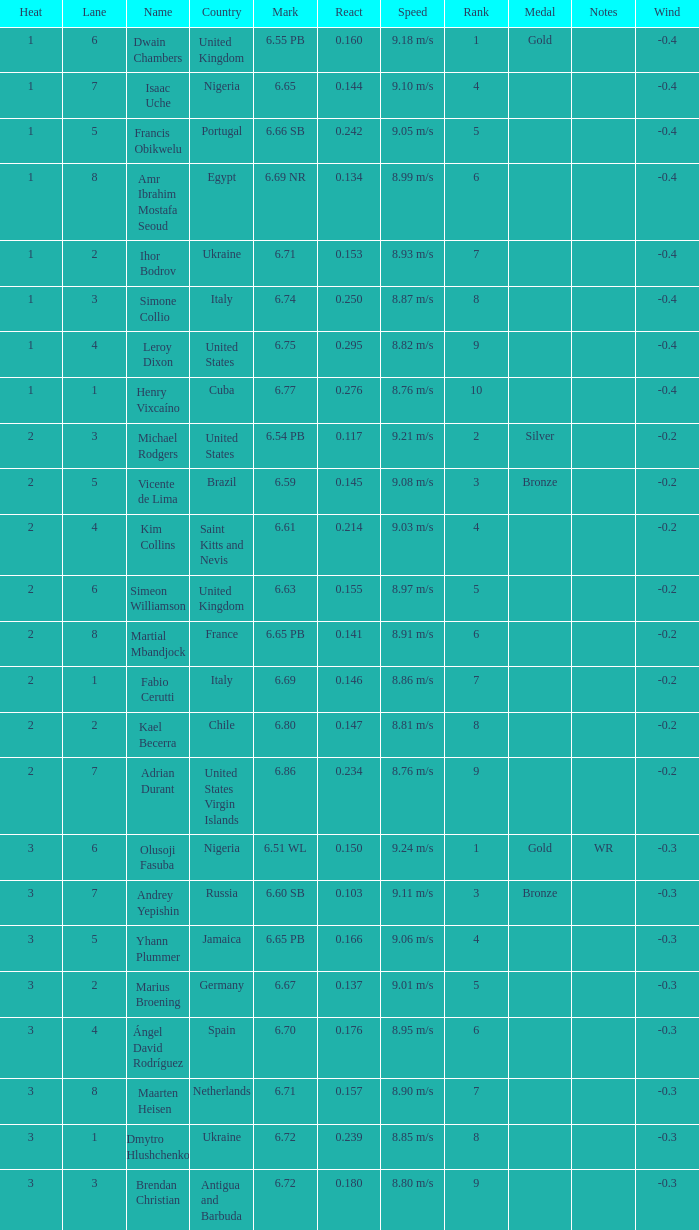69? 2.0. 